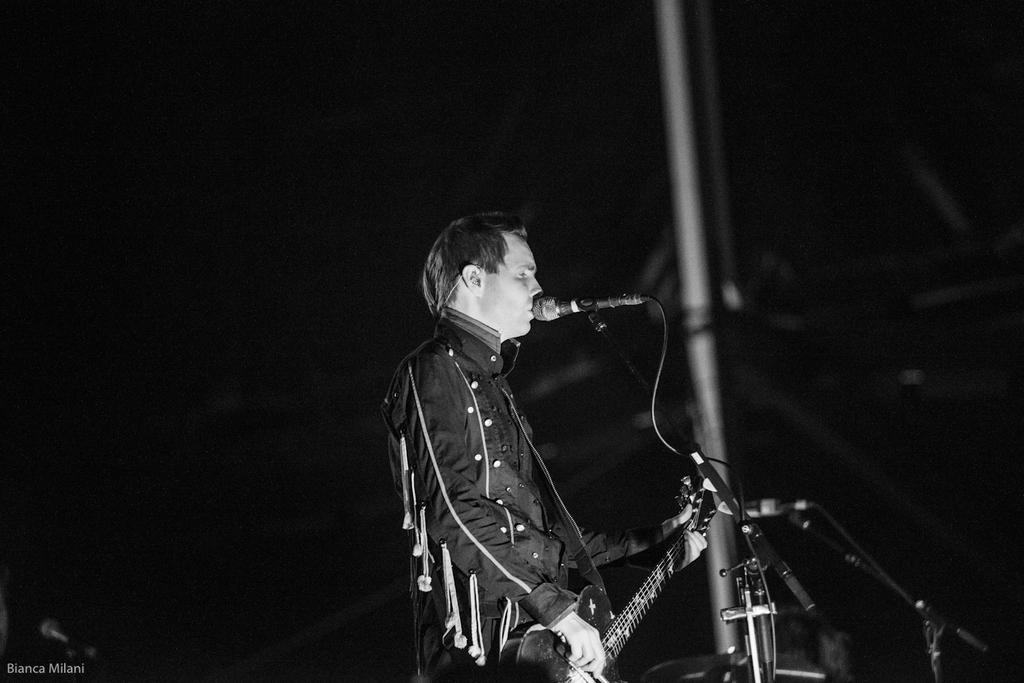What is the person in the image doing? The person is playing a guitar and singing. What is the person wearing in the image? The person is wearing a black dress. What object is present in the image that is typically used for amplifying sound? There is a microphone in the image. How many snails can be seen crawling on the person's mitten in the image? There is no mitten or snails present in the image. 